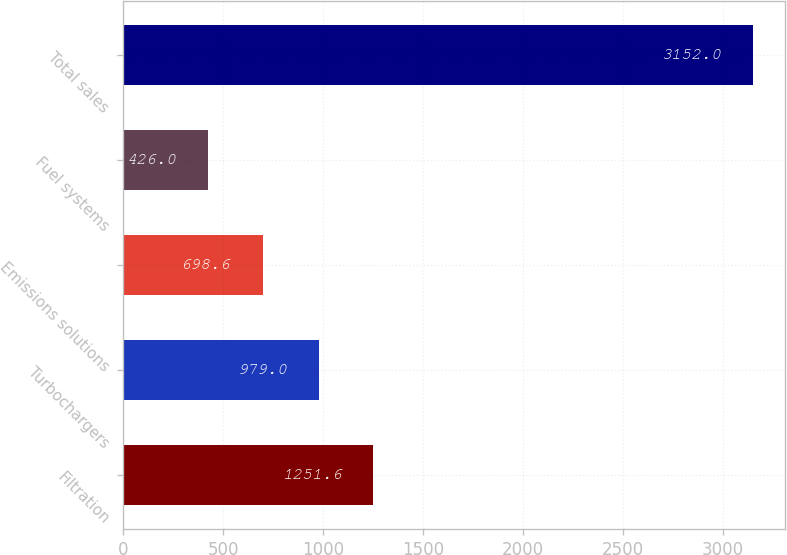<chart> <loc_0><loc_0><loc_500><loc_500><bar_chart><fcel>Filtration<fcel>Turbochargers<fcel>Emissions solutions<fcel>Fuel systems<fcel>Total sales<nl><fcel>1251.6<fcel>979<fcel>698.6<fcel>426<fcel>3152<nl></chart> 